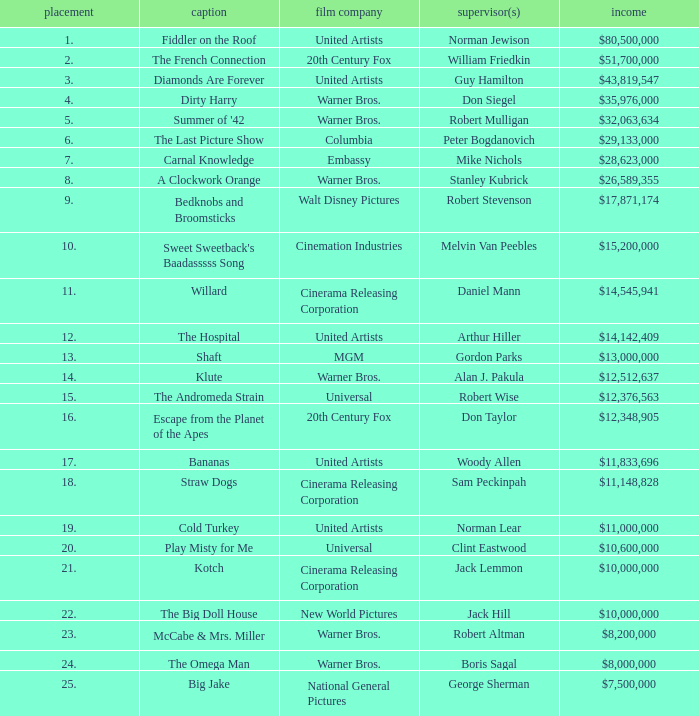How is the big doll house ranked? 22.0. 